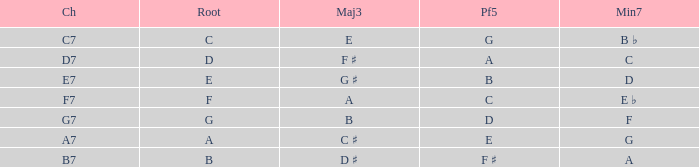What is the Chord with a Minor that is seventh of f? G7. 